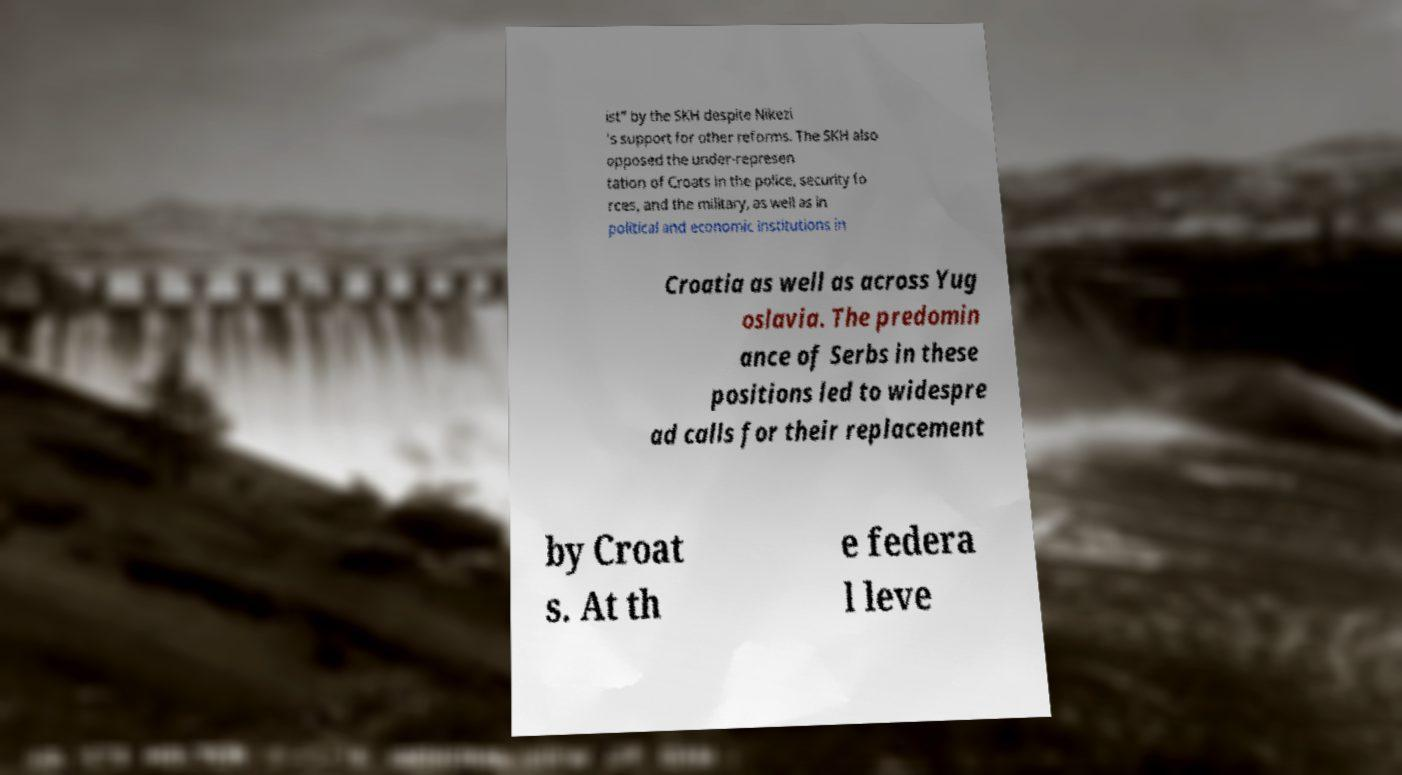Can you accurately transcribe the text from the provided image for me? ist" by the SKH despite Nikezi 's support for other reforms. The SKH also opposed the under-represen tation of Croats in the police, security fo rces, and the military, as well as in political and economic institutions in Croatia as well as across Yug oslavia. The predomin ance of Serbs in these positions led to widespre ad calls for their replacement by Croat s. At th e federa l leve 